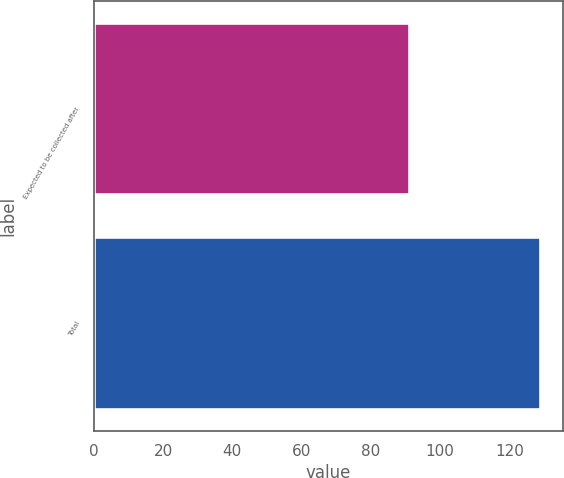<chart> <loc_0><loc_0><loc_500><loc_500><bar_chart><fcel>Expected to be collected after<fcel>Total<nl><fcel>91<fcel>129<nl></chart> 